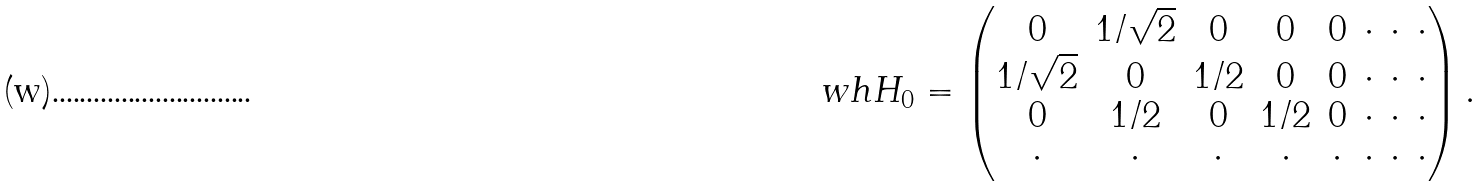<formula> <loc_0><loc_0><loc_500><loc_500>\ w h { H } _ { 0 } = \begin{pmatrix} 0 & 1 / \sqrt { 2 } & 0 & 0 & 0 & \cdot & \cdot & \cdot \\ 1 / \sqrt { 2 } & 0 & 1 / 2 & 0 & 0 & \cdot & \cdot & \cdot \\ 0 & 1 / 2 & 0 & 1 / 2 & 0 & \cdot & \cdot & \cdot \\ \cdot & \cdot & \cdot & \cdot & \cdot & \cdot & \cdot & \cdot \\ \end{pmatrix} .</formula> 